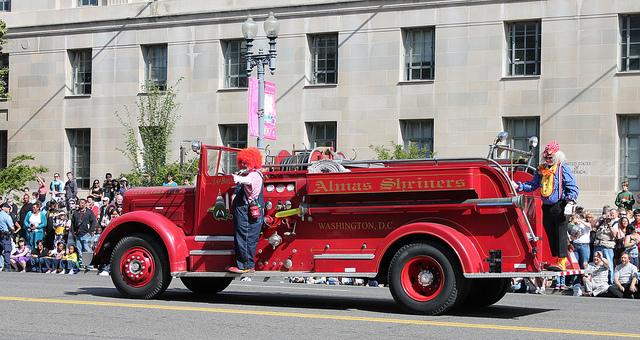Extract all visible text content from this image. WASHINGTON D. C. Almas 